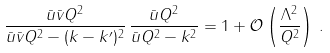Convert formula to latex. <formula><loc_0><loc_0><loc_500><loc_500>\frac { \bar { u } \bar { v } Q ^ { 2 } } { \bar { u } \bar { v } Q ^ { 2 } - ( k - k ^ { \prime } ) ^ { 2 } } \, \frac { \bar { u } Q ^ { 2 } } { \bar { u } Q ^ { 2 } - k ^ { 2 } } = 1 + \mathcal { O } \left ( \frac { \Lambda ^ { 2 } } { Q ^ { 2 } } \right ) \, .</formula> 